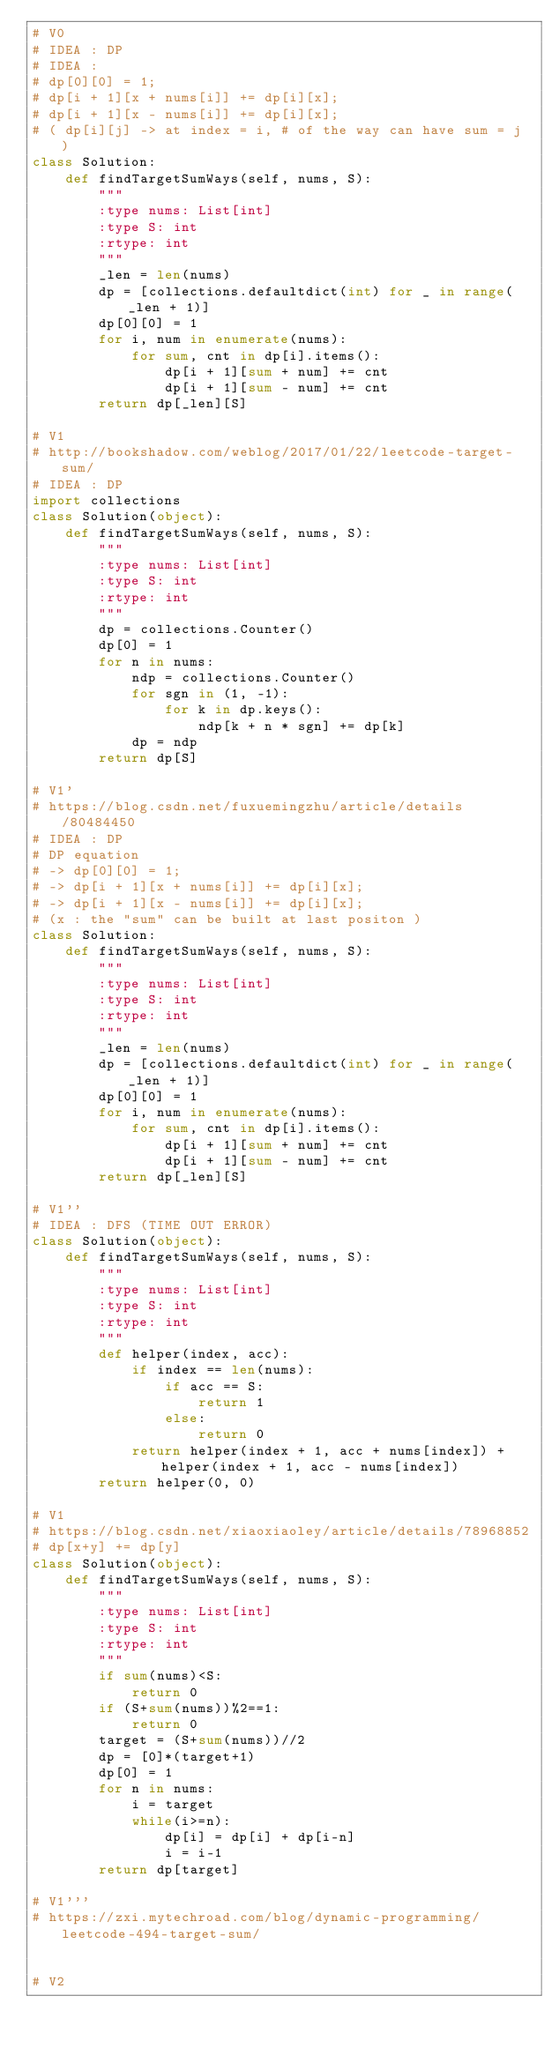<code> <loc_0><loc_0><loc_500><loc_500><_Python_># V0 
# IDEA : DP 
# IDEA :
# dp[0][0] = 1;
# dp[i + 1][x + nums[i]] += dp[i][x];
# dp[i + 1][x - nums[i]] += dp[i][x];
# ( dp[i][j] -> at index = i, # of the way can have sum = j )
class Solution:
    def findTargetSumWays(self, nums, S):
        """
        :type nums: List[int]
        :type S: int
        :rtype: int
        """
        _len = len(nums)
        dp = [collections.defaultdict(int) for _ in range(_len + 1)] 
        dp[0][0] = 1
        for i, num in enumerate(nums):
            for sum, cnt in dp[i].items():
                dp[i + 1][sum + num] += cnt
                dp[i + 1][sum - num] += cnt
        return dp[_len][S]

# V1
# http://bookshadow.com/weblog/2017/01/22/leetcode-target-sum/
# IDEA : DP
import collections
class Solution(object):
    def findTargetSumWays(self, nums, S):
        """
        :type nums: List[int]
        :type S: int
        :rtype: int
        """
        dp = collections.Counter()
        dp[0] = 1
        for n in nums:
            ndp = collections.Counter()
            for sgn in (1, -1):
                for k in dp.keys():
                    ndp[k + n * sgn] += dp[k]
            dp = ndp
        return dp[S]

# V1'
# https://blog.csdn.net/fuxuemingzhu/article/details/80484450
# IDEA : DP
# DP equation 
# -> dp[0][0] = 1;
# -> dp[i + 1][x + nums[i]] += dp[i][x];
# -> dp[i + 1][x - nums[i]] += dp[i][x];
# (x : the "sum" can be built at last positon )
class Solution:
    def findTargetSumWays(self, nums, S):
        """
        :type nums: List[int]
        :type S: int
        :rtype: int
        """
        _len = len(nums)
        dp = [collections.defaultdict(int) for _ in range(_len + 1)] 
        dp[0][0] = 1
        for i, num in enumerate(nums):
            for sum, cnt in dp[i].items():
                dp[i + 1][sum + num] += cnt
                dp[i + 1][sum - num] += cnt
        return dp[_len][S]

# V1''
# IDEA : DFS (TIME OUT ERROR)
class Solution(object):
    def findTargetSumWays(self, nums, S):
        """
        :type nums: List[int]
        :type S: int
        :rtype: int
        """
        def helper(index, acc):
            if index == len(nums):
                if acc == S:
                    return 1
                else:
                    return 0
            return helper(index + 1, acc + nums[index]) + helper(index + 1, acc - nums[index])
        return helper(0, 0)

# V1
# https://blog.csdn.net/xiaoxiaoley/article/details/78968852
# dp[x+y] += dp[y]
class Solution(object):
    def findTargetSumWays(self, nums, S):
        """
        :type nums: List[int]
        :type S: int
        :rtype: int
        """
        if sum(nums)<S:
            return 0
        if (S+sum(nums))%2==1:
            return 0
        target = (S+sum(nums))//2
        dp = [0]*(target+1)
        dp[0] = 1
        for n in nums:
            i = target
            while(i>=n):
                dp[i] = dp[i] + dp[i-n]
                i = i-1
        return dp[target]

# V1'''
# https://zxi.mytechroad.com/blog/dynamic-programming/leetcode-494-target-sum/


# V2
</code> 